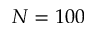Convert formula to latex. <formula><loc_0><loc_0><loc_500><loc_500>N = 1 0 0</formula> 